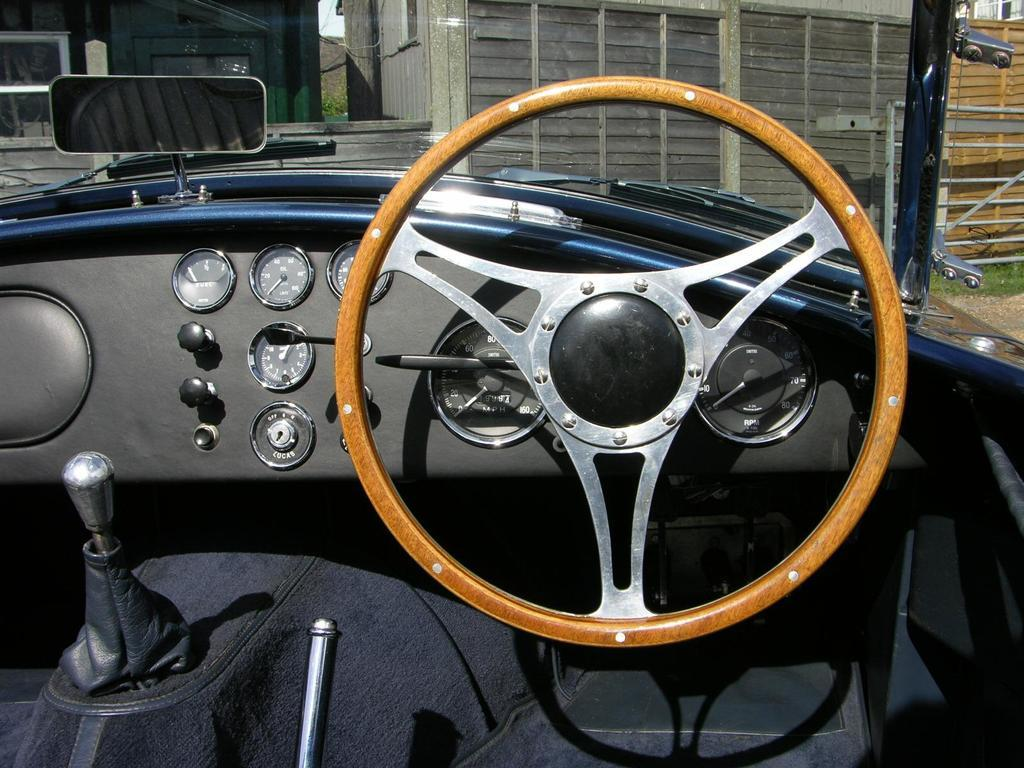What is the main subject in the center of the image? There is a vehicle in the center of the image. What can be seen in the background of the image? There are sheds and a fence in the background of the image. What type of stone is the woman holding in the image? There is no woman or stone present in the image. 